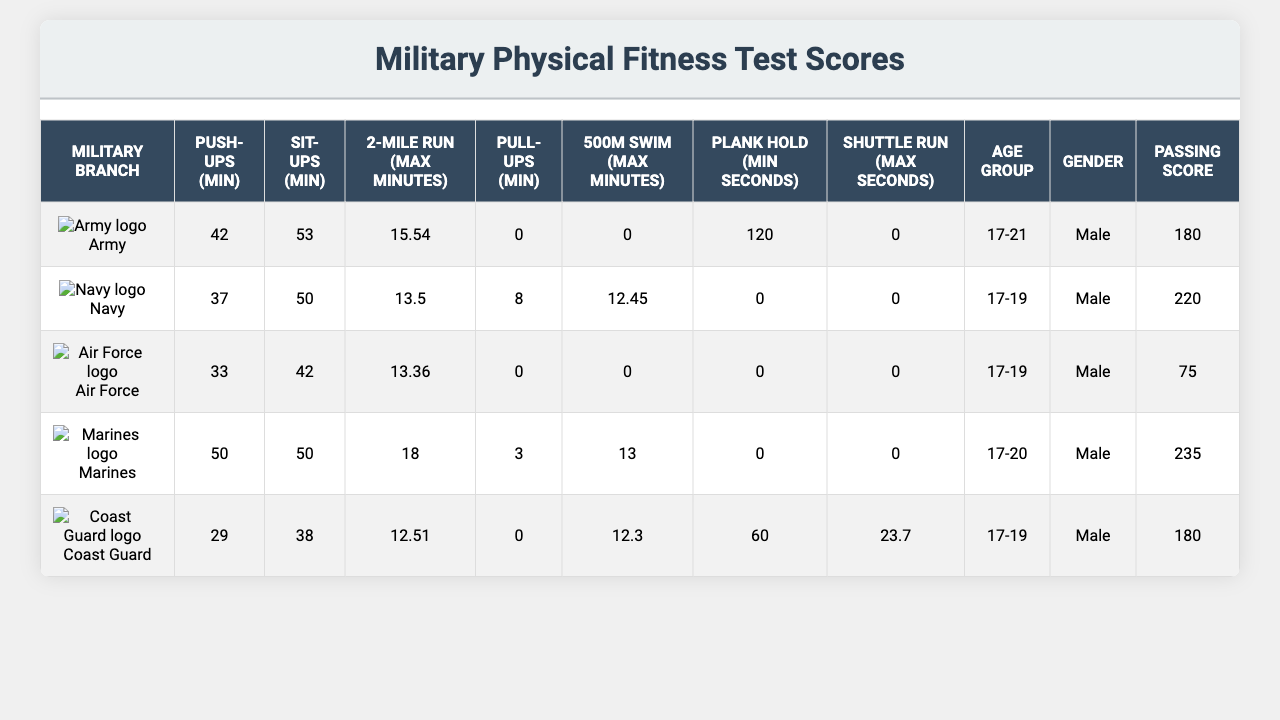What is the maximum number of push-ups required by the Marines? According to the table, the Marines have a requirement of 50 push-ups.
Answer: 50 Which branch has the lowest requirement for sit-ups? By examining the sit-up requirements in the table, the Coast Guard has the lowest requirement of 38 sit-ups.
Answer: 38 What is the passing score for the Navy? The passing score for the Navy is listed as 220 in the table.
Answer: 220 How many minutes is allowed for the two-mile run in the Air Force? The table indicates that the Air Force allows a maximum of 13.36 minutes for the two-mile run.
Answer: 13.36 Do all branches require a plank hold duration? The table shows that the Navy, Air Force, and Marines do not have any requirement for the plank hold, indicating that not all branches require it.
Answer: Yes Which branch has the highest passing score, and what is that score? The Marines have the highest passing score of 235 according to the table.
Answer: 235 What is the average maximum time allowed for the 500m swim across all branches? Summing the swim times: 12.45 + 13 + 12.3 = 37.75 and dividing by 4 (since Coast Guard has no requirement): 37.75 / 4 = 9.4375. Total time is not applicable for every branch, and thus the average is based on available data.
Answer: 9.4375 If someone can do exactly 50 push-ups, which branches would they qualify for? Looking at the push-up minimums, they would qualify for the Army, Marines, and Coast Guard since they require 42, 50, and 29 push-ups respectively.
Answer: Army, Marines, Coast Guard Which military branch has the most stringent (highest) maximum time for the two-mile run? The Marines have the highest maximum time listed for the two-mile run, which is 18 minutes.
Answer: 18 Is there any branch that does not require pull-ups? The table indicates that the Army, Air Force, and Coast Guard have no minimum requirement for pull-ups. Therefore, they do not require them.
Answer: Yes 